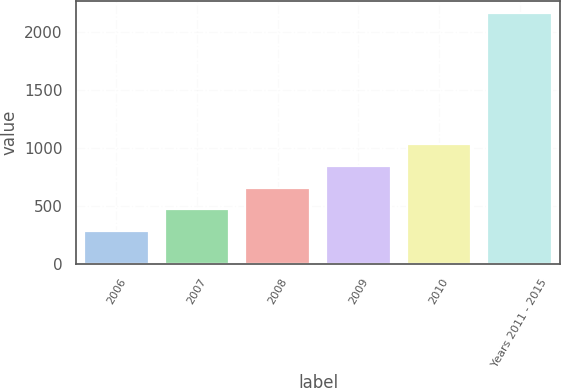Convert chart. <chart><loc_0><loc_0><loc_500><loc_500><bar_chart><fcel>2006<fcel>2007<fcel>2008<fcel>2009<fcel>2010<fcel>Years 2011 - 2015<nl><fcel>280<fcel>467.9<fcel>655.8<fcel>843.7<fcel>1031.6<fcel>2159<nl></chart> 